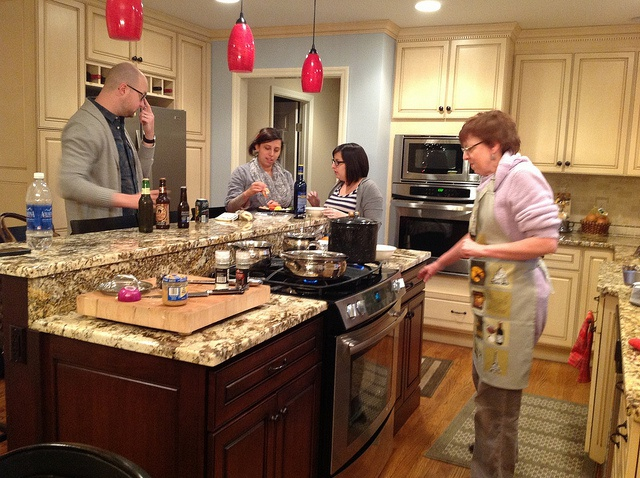Describe the objects in this image and their specific colors. I can see people in gray, tan, maroon, and brown tones, people in gray and tan tones, oven in gray, black, and maroon tones, oven in gray, black, and maroon tones, and people in gray, darkgray, and maroon tones in this image. 